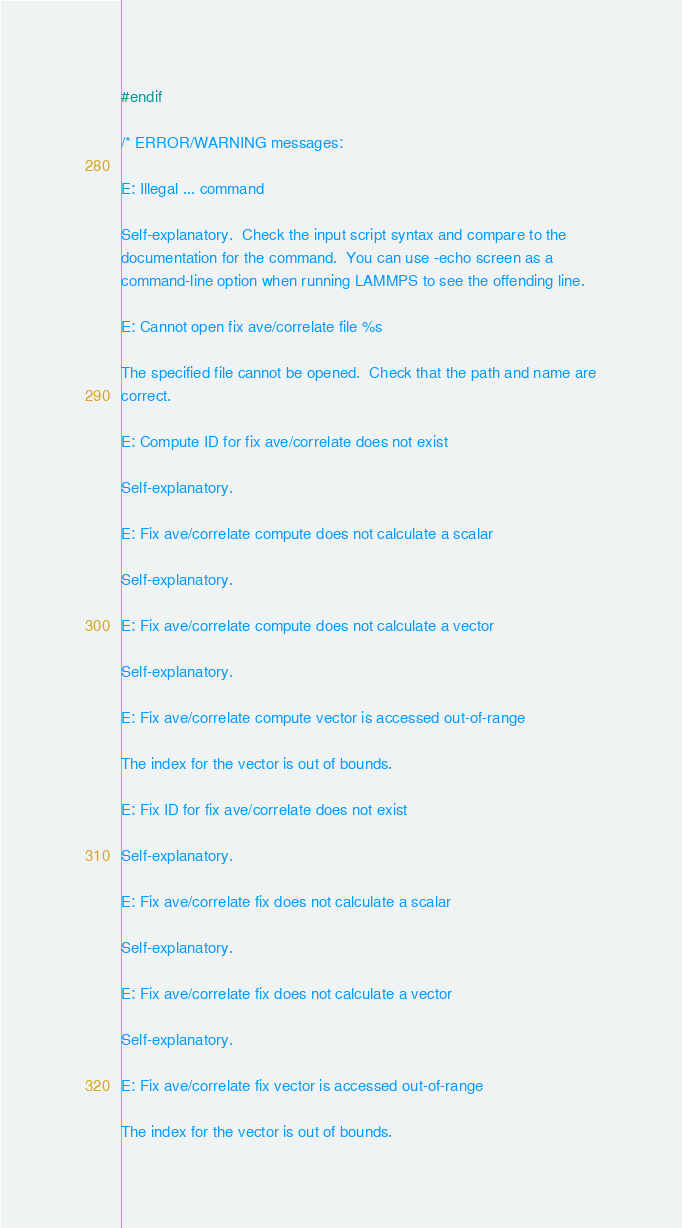<code> <loc_0><loc_0><loc_500><loc_500><_C_>#endif

/* ERROR/WARNING messages:

E: Illegal ... command

Self-explanatory.  Check the input script syntax and compare to the
documentation for the command.  You can use -echo screen as a
command-line option when running LAMMPS to see the offending line.

E: Cannot open fix ave/correlate file %s

The specified file cannot be opened.  Check that the path and name are
correct.

E: Compute ID for fix ave/correlate does not exist

Self-explanatory.

E: Fix ave/correlate compute does not calculate a scalar

Self-explanatory.

E: Fix ave/correlate compute does not calculate a vector

Self-explanatory.

E: Fix ave/correlate compute vector is accessed out-of-range

The index for the vector is out of bounds.

E: Fix ID for fix ave/correlate does not exist

Self-explanatory.

E: Fix ave/correlate fix does not calculate a scalar

Self-explanatory.

E: Fix ave/correlate fix does not calculate a vector

Self-explanatory.

E: Fix ave/correlate fix vector is accessed out-of-range

The index for the vector is out of bounds.
</code> 